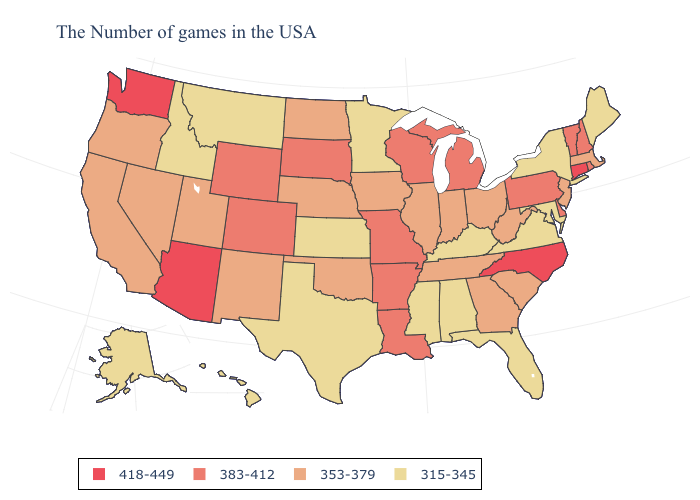Does the first symbol in the legend represent the smallest category?
Write a very short answer. No. What is the value of South Carolina?
Short answer required. 353-379. Name the states that have a value in the range 418-449?
Short answer required. Connecticut, North Carolina, Arizona, Washington. Which states hav the highest value in the South?
Give a very brief answer. North Carolina. What is the lowest value in the Northeast?
Be succinct. 315-345. Which states have the highest value in the USA?
Short answer required. Connecticut, North Carolina, Arizona, Washington. Does Illinois have the same value as Washington?
Short answer required. No. Does Tennessee have the same value as Delaware?
Keep it brief. No. What is the highest value in the USA?
Keep it brief. 418-449. Which states have the lowest value in the USA?
Short answer required. Maine, New York, Maryland, Virginia, Florida, Kentucky, Alabama, Mississippi, Minnesota, Kansas, Texas, Montana, Idaho, Alaska, Hawaii. Does Washington have a higher value than Louisiana?
Short answer required. Yes. What is the value of Tennessee?
Concise answer only. 353-379. What is the highest value in the USA?
Quick response, please. 418-449. What is the lowest value in the West?
Answer briefly. 315-345. What is the value of Kansas?
Give a very brief answer. 315-345. 